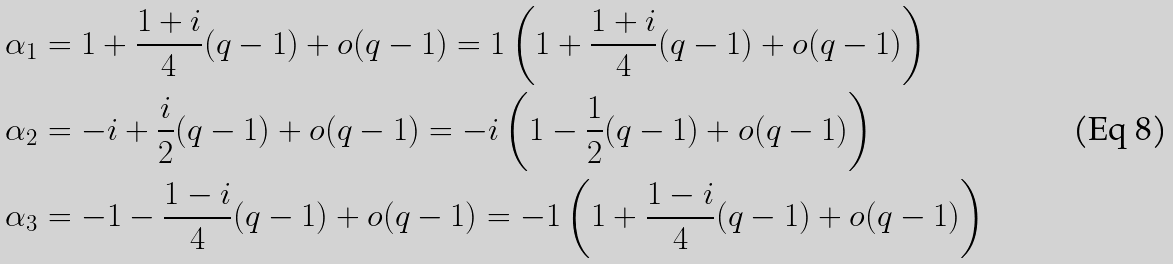Convert formula to latex. <formula><loc_0><loc_0><loc_500><loc_500>\alpha _ { 1 } & = 1 + \frac { 1 + i } { 4 } ( q - 1 ) + o ( q - 1 ) = 1 \left ( 1 + \frac { 1 + i } { 4 } ( q - 1 ) + o ( q - 1 ) \right ) \\ \alpha _ { 2 } & = - i + \frac { i } { 2 } ( q - 1 ) + o ( q - 1 ) = - i \left ( 1 - \frac { 1 } { 2 } ( q - 1 ) + o ( q - 1 ) \right ) \\ \alpha _ { 3 } & = - 1 - \frac { 1 - i } { 4 } ( q - 1 ) + o ( q - 1 ) = - 1 \left ( 1 + \frac { 1 - i } { 4 } ( q - 1 ) + o ( q - 1 ) \right )</formula> 